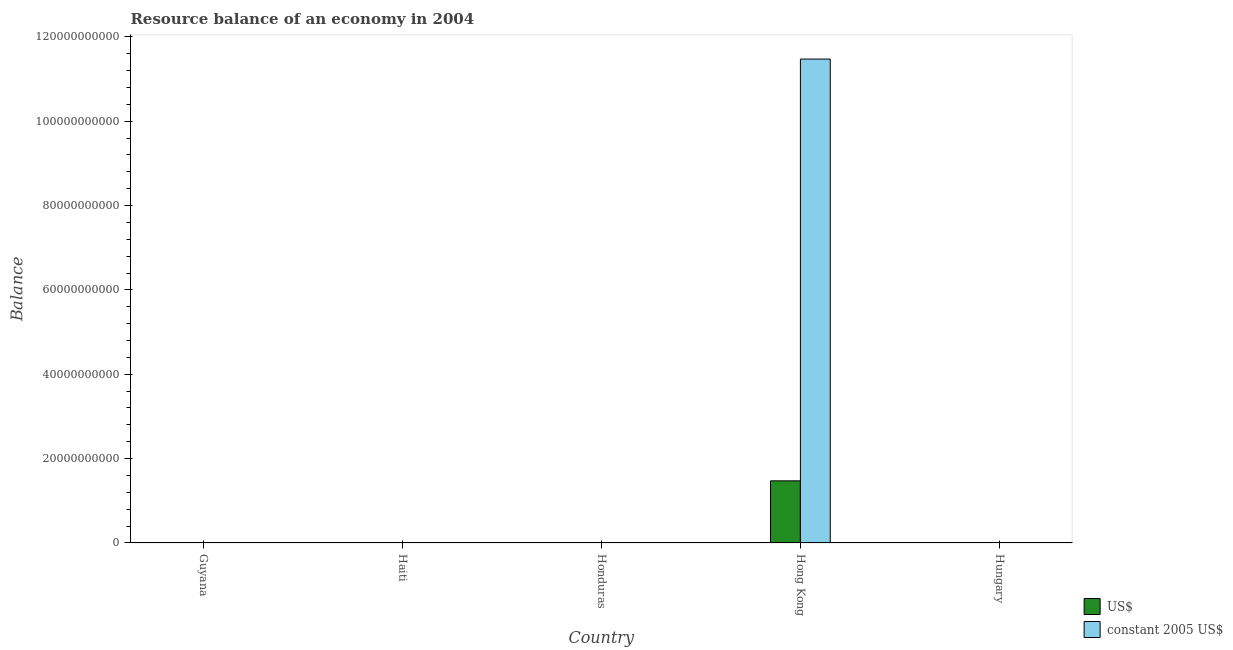How many different coloured bars are there?
Offer a very short reply. 2. Are the number of bars per tick equal to the number of legend labels?
Ensure brevity in your answer.  No. How many bars are there on the 1st tick from the right?
Offer a terse response. 0. What is the label of the 1st group of bars from the left?
Offer a very short reply. Guyana. In how many cases, is the number of bars for a given country not equal to the number of legend labels?
Offer a terse response. 4. Across all countries, what is the maximum resource balance in us$?
Your response must be concise. 1.47e+1. Across all countries, what is the minimum resource balance in us$?
Offer a terse response. 0. In which country was the resource balance in constant us$ maximum?
Your answer should be very brief. Hong Kong. What is the total resource balance in constant us$ in the graph?
Offer a very short reply. 1.15e+11. What is the difference between the resource balance in us$ in Guyana and the resource balance in constant us$ in Hong Kong?
Provide a succinct answer. -1.15e+11. What is the average resource balance in constant us$ per country?
Give a very brief answer. 2.29e+1. What is the difference between the resource balance in us$ and resource balance in constant us$ in Hong Kong?
Offer a very short reply. -1.00e+11. In how many countries, is the resource balance in us$ greater than 44000000000 units?
Keep it short and to the point. 0. What is the difference between the highest and the lowest resource balance in us$?
Offer a very short reply. 1.47e+1. In how many countries, is the resource balance in us$ greater than the average resource balance in us$ taken over all countries?
Your answer should be compact. 1. How many countries are there in the graph?
Keep it short and to the point. 5. Does the graph contain any zero values?
Offer a terse response. Yes. Does the graph contain grids?
Ensure brevity in your answer.  No. Where does the legend appear in the graph?
Provide a short and direct response. Bottom right. What is the title of the graph?
Offer a terse response. Resource balance of an economy in 2004. Does "Export" appear as one of the legend labels in the graph?
Give a very brief answer. No. What is the label or title of the Y-axis?
Keep it short and to the point. Balance. What is the Balance in US$ in Guyana?
Make the answer very short. 0. What is the Balance of constant 2005 US$ in Haiti?
Your answer should be compact. 0. What is the Balance of US$ in Hong Kong?
Keep it short and to the point. 1.47e+1. What is the Balance of constant 2005 US$ in Hong Kong?
Your answer should be very brief. 1.15e+11. What is the Balance in US$ in Hungary?
Keep it short and to the point. 0. What is the Balance in constant 2005 US$ in Hungary?
Give a very brief answer. 0. Across all countries, what is the maximum Balance in US$?
Provide a succinct answer. 1.47e+1. Across all countries, what is the maximum Balance of constant 2005 US$?
Make the answer very short. 1.15e+11. Across all countries, what is the minimum Balance of constant 2005 US$?
Your response must be concise. 0. What is the total Balance of US$ in the graph?
Ensure brevity in your answer.  1.47e+1. What is the total Balance of constant 2005 US$ in the graph?
Offer a very short reply. 1.15e+11. What is the average Balance in US$ per country?
Give a very brief answer. 2.95e+09. What is the average Balance in constant 2005 US$ per country?
Offer a very short reply. 2.29e+1. What is the difference between the Balance of US$ and Balance of constant 2005 US$ in Hong Kong?
Your answer should be very brief. -1.00e+11. What is the difference between the highest and the lowest Balance in US$?
Make the answer very short. 1.47e+1. What is the difference between the highest and the lowest Balance in constant 2005 US$?
Your answer should be compact. 1.15e+11. 